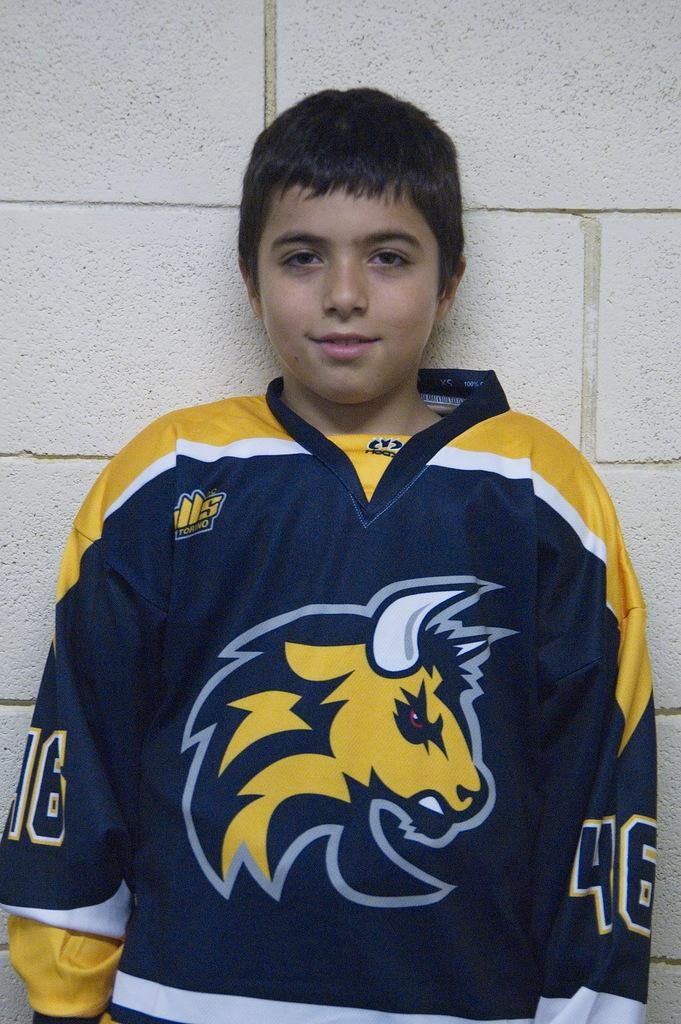Who is the main subject in the image? There is a boy in the image. What is the boy doing in the image? The boy is standing. What is the boy wearing in the image? The boy appears to be wearing a jersey t-shirt. What can be seen behind the boy in the image? There is a wall behind the boy. How many tomatoes are on the boy's head in the image? There are no tomatoes present in the image, and therefore none can be found on the boy's head. 